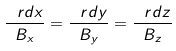<formula> <loc_0><loc_0><loc_500><loc_500>\frac { \ r d x } { B _ { x } } = \frac { \ r d y } { B _ { y } } = \frac { \ r d z } { B _ { z } }</formula> 